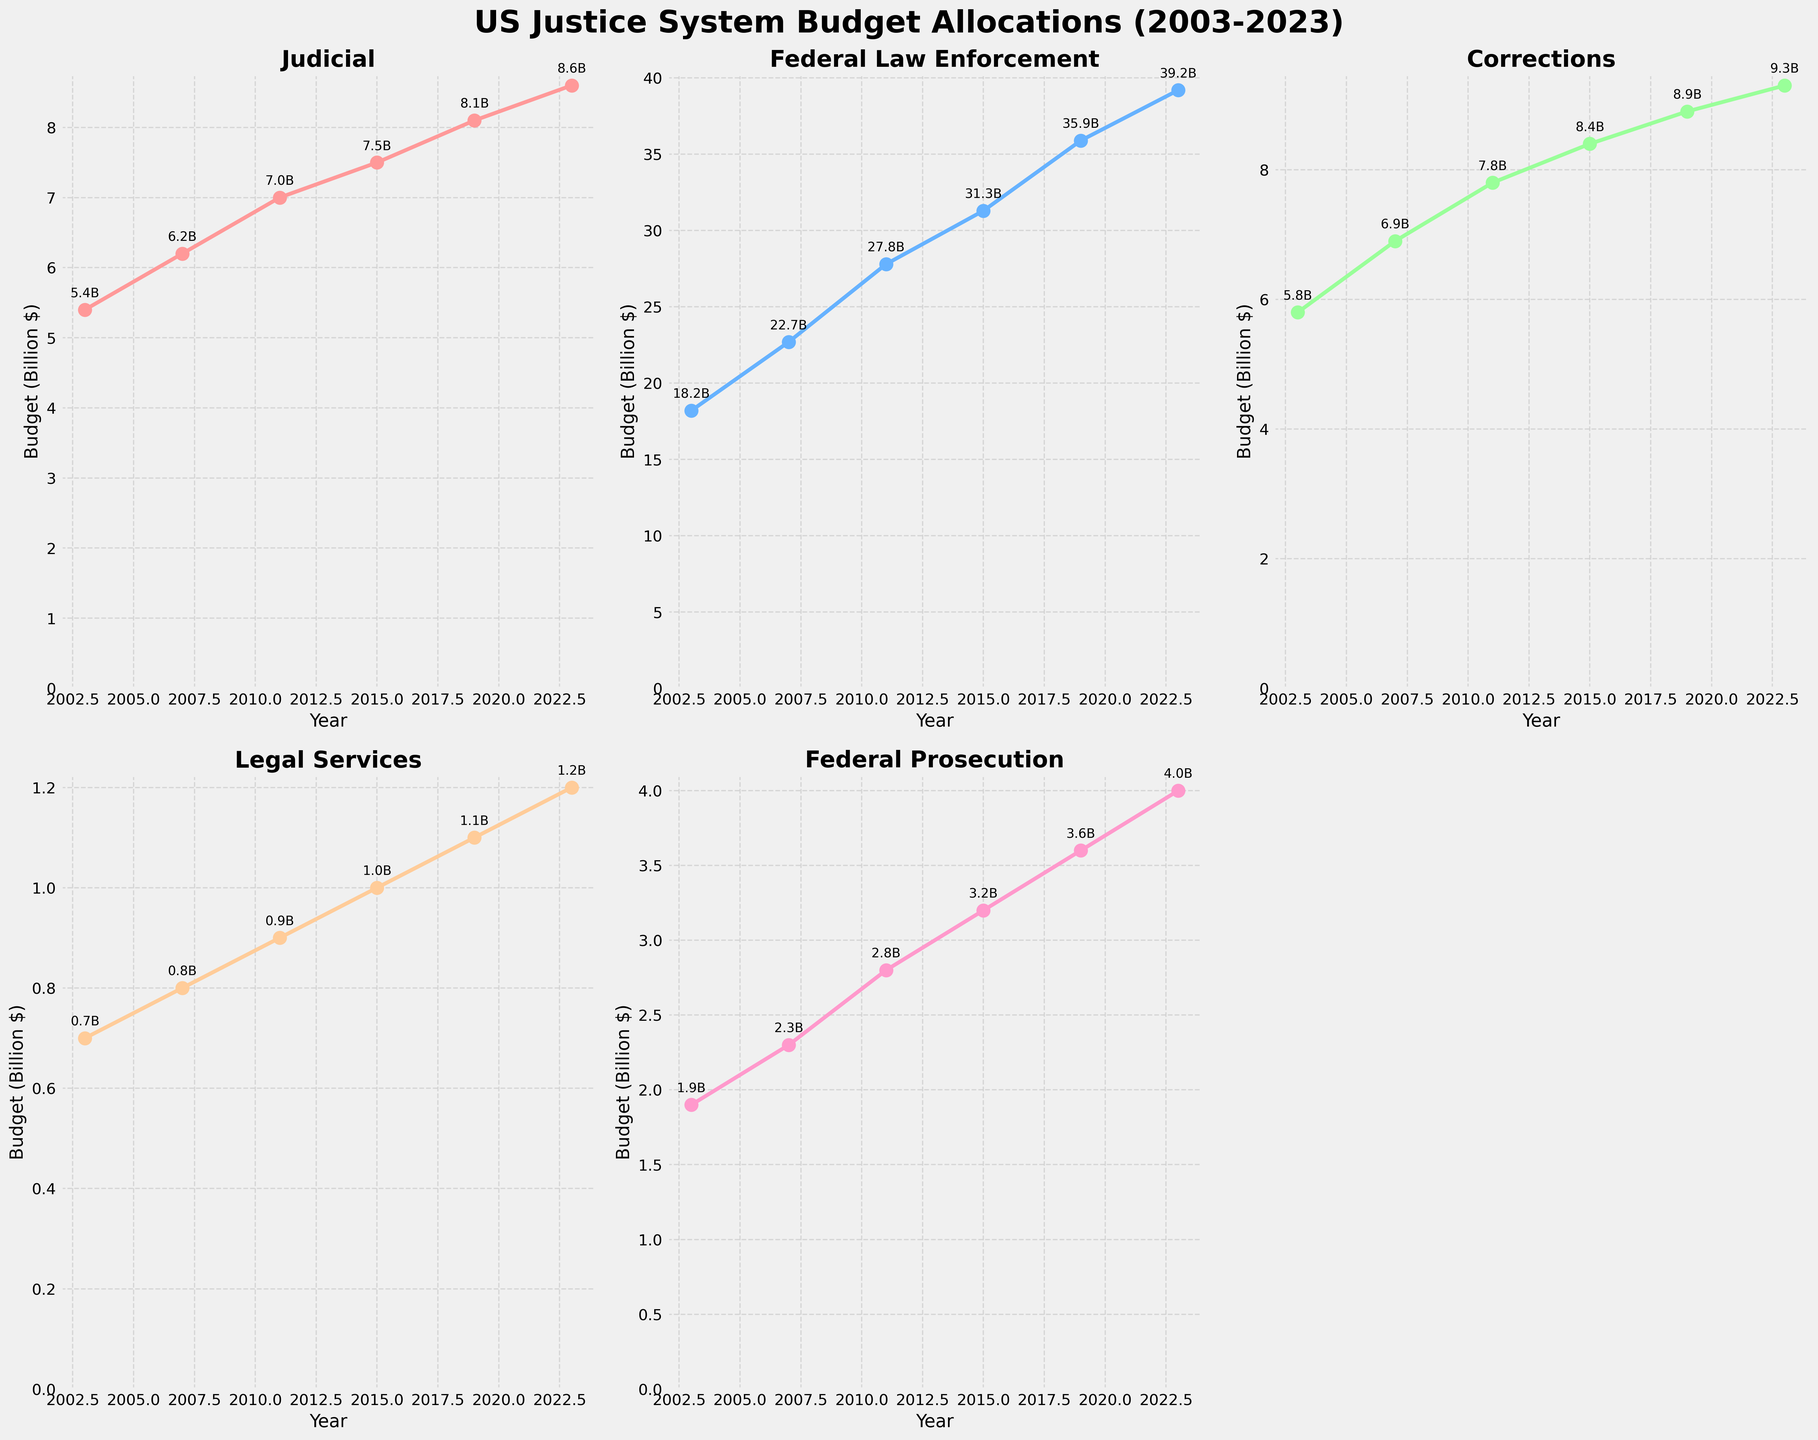What is the overall trend in the budget allocation for Federal Law Enforcement from 2003 to 2023? By observing the line plot for Federal Law Enforcement, it shows a consistent upward trend from 18.2 billion in 2003 to 39.2 billion in 2023.
Answer: Increasing How much did the Corrections budget increase from 2003 to 2011? The budget for Corrections in 2003 was 5.8 billion, and in 2011 it was 7.8 billion. The increase is calculated as 7.8 - 5.8 = 2 billion.
Answer: 2 billion Which category had the smallest budget allocation in 2023? By looking at each of the subplots for the year 2023, it is evident that Legal Services had the smallest budget allocation at 1.2 billion dollars.
Answer: Legal Services Compare the budget allocations for Judicial and Federal Prosecution in 2019. Which one was higher? In 2019, the Judicial budget was 8.1 billion, and the Federal Prosecution budget was 3.6 billion. The Judicial budget was higher.
Answer: Judicial What was the average budget allocation for Legal Services across all recorded years? Adding the budget allocations for Legal Services across the years: 0.7 + 0.8 + 0.9 + 1.0 + 1.1 + 1.2 = 5.7. There are 6 data points, so the average is 5.7/6 = 0.95 billion.
Answer: 0.95 billion Which year saw the highest increase in the Federal Law Enforcement budget compared to the previous period? The largest increase can be observed by calculating the differences between consecutive years. The increases are 22.7-18.2 = 4.5 billion (2007), 27.8-22.7 = 5.1 billion (2011), 31.3-27.8 = 3.5 billion (2015), 35.9-31.3 = 4.6 billion (2019), and 39.2-35.9 = 3.3 billion (2023). The highest increase was between 2007 and 2011, which was 5.1 billion.
Answer: 2011 By how much did the Federal Prosecution budget grow between 2003 and 2023? The Federal Prosecution budget in 2003 was 1.9 billion, and it increased to 4.0 billion in 2023. The difference is 4.0 - 1.9 = 2.1 billion.
Answer: 2.1 billion What is the percentage increase in the Judicial budget from 2003 to 2023? The Judicial budget in 2003 was 5.4 billion and increased to 8.6 billion in 2023. The percentage increase is [(8.6-5.4)/5.4] x 100 = 59.26%.
Answer: 59.26% Among all the categories, which one saw the most consistent increase without any declines from 2003 to 2023? By looking at the subplots, all categories show consistent increases, but Judicial and Federal Law Enforcement stand out with steady upward trends in each recorded year.
Answer: Judicial and Federal Law Enforcement 